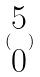Convert formula to latex. <formula><loc_0><loc_0><loc_500><loc_500>( \begin{matrix} 5 \\ 0 \end{matrix} )</formula> 